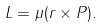<formula> <loc_0><loc_0><loc_500><loc_500>L = \mu ( r \times P ) .</formula> 